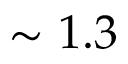<formula> <loc_0><loc_0><loc_500><loc_500>\sim 1 . 3</formula> 